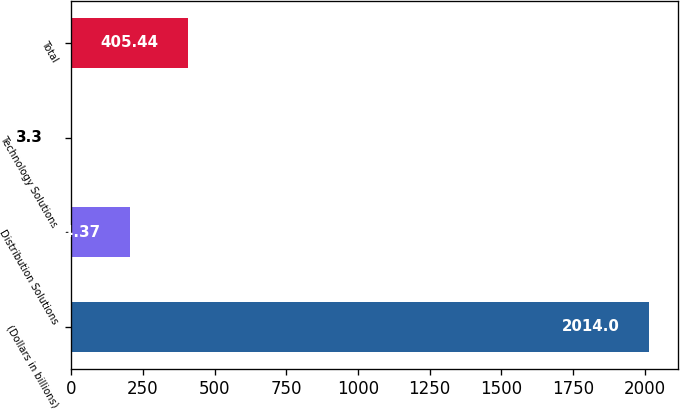<chart> <loc_0><loc_0><loc_500><loc_500><bar_chart><fcel>(Dollars in billions)<fcel>Distribution Solutions<fcel>Technology Solutions<fcel>Total<nl><fcel>2014<fcel>204.37<fcel>3.3<fcel>405.44<nl></chart> 